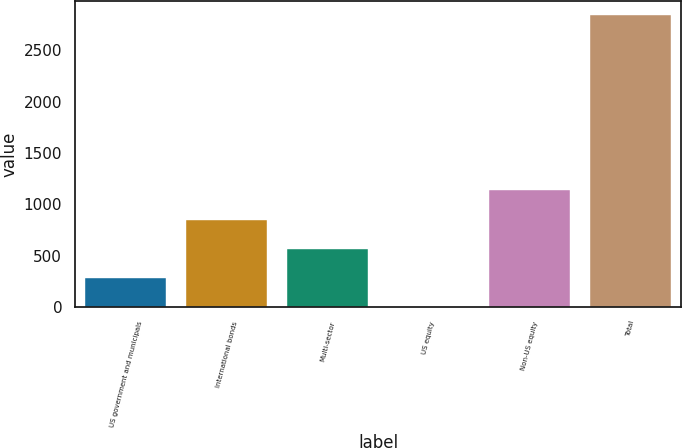Convert chart to OTSL. <chart><loc_0><loc_0><loc_500><loc_500><bar_chart><fcel>US government and municipals<fcel>International bonds<fcel>Multi-sector<fcel>US equity<fcel>Non-US equity<fcel>Total<nl><fcel>285.1<fcel>853.3<fcel>569.2<fcel>1<fcel>1137.4<fcel>2842<nl></chart> 